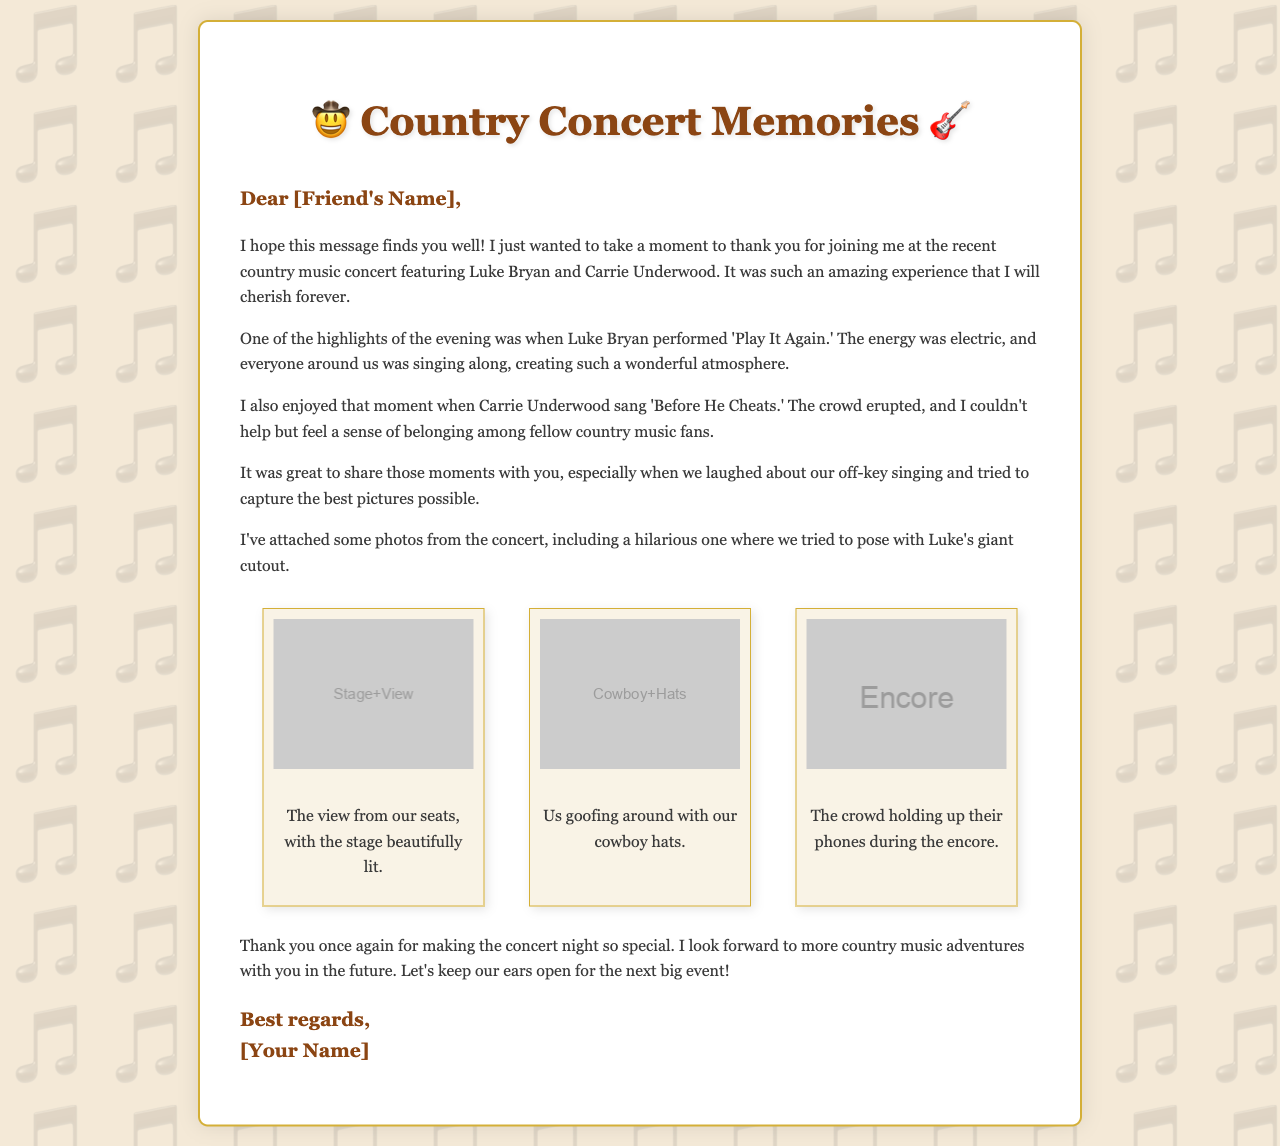What is the name of the concert performers? The document mentions Luke Bryan and Carrie Underwood as the performers at the concert.
Answer: Luke Bryan and Carrie Underwood What song did Luke Bryan perform? The letter states that Luke Bryan performed 'Play It Again.'
Answer: 'Play It Again' What moment did Carrie Underwood perform? The letter highlights Carrie Underwood singing 'Before He Cheats.'
Answer: 'Before He Cheats' How many photos are included in the gallery? The document features three photos from the concert in the photo gallery.
Answer: Three What feeling did the author express about the concert atmosphere? The author describes the atmosphere as "electric" due to the crowd's engagement during performances.
Answer: Electric What did the author and friend do regarding their singing? The author recalls laughing about their off-key singing during the concert.
Answer: Laughed about off-key singing What connection does the author feel with other fans? The author expresses a sense of belonging among fellow country music fans during the concert.
Answer: Sense of belonging What is the main purpose of the letter? The primary purpose of the letter is to thank the friend for joining the concert experience.
Answer: To thank a friend 